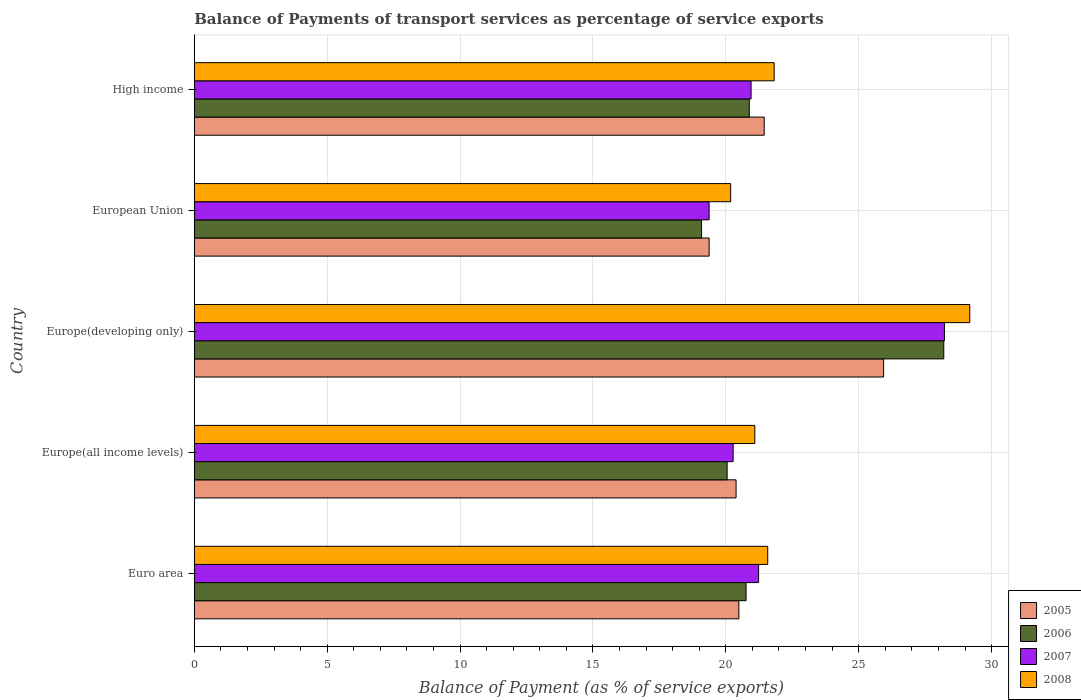Are the number of bars per tick equal to the number of legend labels?
Offer a very short reply. Yes. What is the label of the 5th group of bars from the top?
Keep it short and to the point. Euro area. What is the balance of payments of transport services in 2006 in High income?
Ensure brevity in your answer.  20.88. Across all countries, what is the maximum balance of payments of transport services in 2006?
Your answer should be compact. 28.2. Across all countries, what is the minimum balance of payments of transport services in 2008?
Offer a terse response. 20.18. In which country was the balance of payments of transport services in 2007 maximum?
Provide a succinct answer. Europe(developing only). In which country was the balance of payments of transport services in 2006 minimum?
Provide a succinct answer. European Union. What is the total balance of payments of transport services in 2007 in the graph?
Provide a short and direct response. 110.06. What is the difference between the balance of payments of transport services in 2007 in Euro area and that in European Union?
Make the answer very short. 1.86. What is the difference between the balance of payments of transport services in 2007 in Euro area and the balance of payments of transport services in 2006 in High income?
Your answer should be compact. 0.35. What is the average balance of payments of transport services in 2008 per country?
Give a very brief answer. 22.77. What is the difference between the balance of payments of transport services in 2007 and balance of payments of transport services in 2005 in European Union?
Make the answer very short. -0. In how many countries, is the balance of payments of transport services in 2006 greater than 6 %?
Your answer should be compact. 5. What is the ratio of the balance of payments of transport services in 2006 in Euro area to that in High income?
Provide a succinct answer. 0.99. Is the difference between the balance of payments of transport services in 2007 in European Union and High income greater than the difference between the balance of payments of transport services in 2005 in European Union and High income?
Your response must be concise. Yes. What is the difference between the highest and the second highest balance of payments of transport services in 2007?
Provide a short and direct response. 6.99. What is the difference between the highest and the lowest balance of payments of transport services in 2007?
Give a very brief answer. 8.85. Is the sum of the balance of payments of transport services in 2007 in Europe(all income levels) and European Union greater than the maximum balance of payments of transport services in 2005 across all countries?
Your answer should be compact. Yes. What does the 4th bar from the bottom in Europe(developing only) represents?
Offer a very short reply. 2008. How many bars are there?
Your response must be concise. 20. Are all the bars in the graph horizontal?
Offer a terse response. Yes. How many countries are there in the graph?
Give a very brief answer. 5. Are the values on the major ticks of X-axis written in scientific E-notation?
Your answer should be compact. No. Does the graph contain any zero values?
Keep it short and to the point. No. Does the graph contain grids?
Provide a succinct answer. Yes. How many legend labels are there?
Your answer should be compact. 4. What is the title of the graph?
Offer a terse response. Balance of Payments of transport services as percentage of service exports. What is the label or title of the X-axis?
Your answer should be compact. Balance of Payment (as % of service exports). What is the Balance of Payment (as % of service exports) of 2005 in Euro area?
Provide a short and direct response. 20.49. What is the Balance of Payment (as % of service exports) in 2006 in Euro area?
Your answer should be compact. 20.76. What is the Balance of Payment (as % of service exports) of 2007 in Euro area?
Your answer should be compact. 21.23. What is the Balance of Payment (as % of service exports) in 2008 in Euro area?
Keep it short and to the point. 21.58. What is the Balance of Payment (as % of service exports) of 2005 in Europe(all income levels)?
Offer a terse response. 20.39. What is the Balance of Payment (as % of service exports) of 2006 in Europe(all income levels)?
Provide a short and direct response. 20.05. What is the Balance of Payment (as % of service exports) in 2007 in Europe(all income levels)?
Provide a succinct answer. 20.28. What is the Balance of Payment (as % of service exports) of 2008 in Europe(all income levels)?
Keep it short and to the point. 21.09. What is the Balance of Payment (as % of service exports) of 2005 in Europe(developing only)?
Your response must be concise. 25.94. What is the Balance of Payment (as % of service exports) in 2006 in Europe(developing only)?
Provide a short and direct response. 28.2. What is the Balance of Payment (as % of service exports) in 2007 in Europe(developing only)?
Your response must be concise. 28.23. What is the Balance of Payment (as % of service exports) of 2008 in Europe(developing only)?
Make the answer very short. 29.18. What is the Balance of Payment (as % of service exports) in 2005 in European Union?
Give a very brief answer. 19.37. What is the Balance of Payment (as % of service exports) in 2006 in European Union?
Offer a terse response. 19.09. What is the Balance of Payment (as % of service exports) of 2007 in European Union?
Give a very brief answer. 19.37. What is the Balance of Payment (as % of service exports) of 2008 in European Union?
Offer a very short reply. 20.18. What is the Balance of Payment (as % of service exports) in 2005 in High income?
Your answer should be compact. 21.44. What is the Balance of Payment (as % of service exports) of 2006 in High income?
Ensure brevity in your answer.  20.88. What is the Balance of Payment (as % of service exports) of 2007 in High income?
Your response must be concise. 20.95. What is the Balance of Payment (as % of service exports) in 2008 in High income?
Give a very brief answer. 21.82. Across all countries, what is the maximum Balance of Payment (as % of service exports) of 2005?
Your answer should be compact. 25.94. Across all countries, what is the maximum Balance of Payment (as % of service exports) of 2006?
Provide a short and direct response. 28.2. Across all countries, what is the maximum Balance of Payment (as % of service exports) in 2007?
Offer a very short reply. 28.23. Across all countries, what is the maximum Balance of Payment (as % of service exports) of 2008?
Make the answer very short. 29.18. Across all countries, what is the minimum Balance of Payment (as % of service exports) in 2005?
Keep it short and to the point. 19.37. Across all countries, what is the minimum Balance of Payment (as % of service exports) of 2006?
Give a very brief answer. 19.09. Across all countries, what is the minimum Balance of Payment (as % of service exports) in 2007?
Offer a terse response. 19.37. Across all countries, what is the minimum Balance of Payment (as % of service exports) in 2008?
Offer a very short reply. 20.18. What is the total Balance of Payment (as % of service exports) of 2005 in the graph?
Provide a short and direct response. 107.63. What is the total Balance of Payment (as % of service exports) of 2006 in the graph?
Make the answer very short. 108.98. What is the total Balance of Payment (as % of service exports) of 2007 in the graph?
Offer a terse response. 110.06. What is the total Balance of Payment (as % of service exports) in 2008 in the graph?
Offer a very short reply. 113.85. What is the difference between the Balance of Payment (as % of service exports) in 2005 in Euro area and that in Europe(all income levels)?
Provide a succinct answer. 0.11. What is the difference between the Balance of Payment (as % of service exports) in 2006 in Euro area and that in Europe(all income levels)?
Your answer should be very brief. 0.71. What is the difference between the Balance of Payment (as % of service exports) in 2007 in Euro area and that in Europe(all income levels)?
Provide a short and direct response. 0.96. What is the difference between the Balance of Payment (as % of service exports) in 2008 in Euro area and that in Europe(all income levels)?
Provide a succinct answer. 0.49. What is the difference between the Balance of Payment (as % of service exports) of 2005 in Euro area and that in Europe(developing only)?
Keep it short and to the point. -5.45. What is the difference between the Balance of Payment (as % of service exports) in 2006 in Euro area and that in Europe(developing only)?
Make the answer very short. -7.44. What is the difference between the Balance of Payment (as % of service exports) of 2007 in Euro area and that in Europe(developing only)?
Your answer should be very brief. -6.99. What is the difference between the Balance of Payment (as % of service exports) in 2008 in Euro area and that in Europe(developing only)?
Give a very brief answer. -7.6. What is the difference between the Balance of Payment (as % of service exports) in 2005 in Euro area and that in European Union?
Offer a very short reply. 1.12. What is the difference between the Balance of Payment (as % of service exports) in 2006 in Euro area and that in European Union?
Your answer should be compact. 1.68. What is the difference between the Balance of Payment (as % of service exports) of 2007 in Euro area and that in European Union?
Your answer should be very brief. 1.86. What is the difference between the Balance of Payment (as % of service exports) in 2008 in Euro area and that in European Union?
Ensure brevity in your answer.  1.39. What is the difference between the Balance of Payment (as % of service exports) of 2005 in Euro area and that in High income?
Your answer should be very brief. -0.95. What is the difference between the Balance of Payment (as % of service exports) in 2006 in Euro area and that in High income?
Keep it short and to the point. -0.12. What is the difference between the Balance of Payment (as % of service exports) in 2007 in Euro area and that in High income?
Provide a succinct answer. 0.28. What is the difference between the Balance of Payment (as % of service exports) of 2008 in Euro area and that in High income?
Ensure brevity in your answer.  -0.24. What is the difference between the Balance of Payment (as % of service exports) of 2005 in Europe(all income levels) and that in Europe(developing only)?
Ensure brevity in your answer.  -5.55. What is the difference between the Balance of Payment (as % of service exports) of 2006 in Europe(all income levels) and that in Europe(developing only)?
Ensure brevity in your answer.  -8.15. What is the difference between the Balance of Payment (as % of service exports) of 2007 in Europe(all income levels) and that in Europe(developing only)?
Offer a terse response. -7.95. What is the difference between the Balance of Payment (as % of service exports) in 2008 in Europe(all income levels) and that in Europe(developing only)?
Offer a very short reply. -8.09. What is the difference between the Balance of Payment (as % of service exports) of 2005 in Europe(all income levels) and that in European Union?
Provide a short and direct response. 1.01. What is the difference between the Balance of Payment (as % of service exports) in 2006 in Europe(all income levels) and that in European Union?
Offer a terse response. 0.96. What is the difference between the Balance of Payment (as % of service exports) in 2007 in Europe(all income levels) and that in European Union?
Your answer should be very brief. 0.9. What is the difference between the Balance of Payment (as % of service exports) in 2008 in Europe(all income levels) and that in European Union?
Ensure brevity in your answer.  0.91. What is the difference between the Balance of Payment (as % of service exports) in 2005 in Europe(all income levels) and that in High income?
Keep it short and to the point. -1.06. What is the difference between the Balance of Payment (as % of service exports) in 2006 in Europe(all income levels) and that in High income?
Your answer should be compact. -0.83. What is the difference between the Balance of Payment (as % of service exports) in 2007 in Europe(all income levels) and that in High income?
Your response must be concise. -0.67. What is the difference between the Balance of Payment (as % of service exports) in 2008 in Europe(all income levels) and that in High income?
Make the answer very short. -0.73. What is the difference between the Balance of Payment (as % of service exports) in 2005 in Europe(developing only) and that in European Union?
Make the answer very short. 6.56. What is the difference between the Balance of Payment (as % of service exports) in 2006 in Europe(developing only) and that in European Union?
Keep it short and to the point. 9.11. What is the difference between the Balance of Payment (as % of service exports) of 2007 in Europe(developing only) and that in European Union?
Your response must be concise. 8.85. What is the difference between the Balance of Payment (as % of service exports) in 2008 in Europe(developing only) and that in European Union?
Make the answer very short. 9. What is the difference between the Balance of Payment (as % of service exports) of 2005 in Europe(developing only) and that in High income?
Your answer should be compact. 4.49. What is the difference between the Balance of Payment (as % of service exports) in 2006 in Europe(developing only) and that in High income?
Ensure brevity in your answer.  7.32. What is the difference between the Balance of Payment (as % of service exports) of 2007 in Europe(developing only) and that in High income?
Give a very brief answer. 7.28. What is the difference between the Balance of Payment (as % of service exports) of 2008 in Europe(developing only) and that in High income?
Your answer should be very brief. 7.36. What is the difference between the Balance of Payment (as % of service exports) in 2005 in European Union and that in High income?
Offer a terse response. -2.07. What is the difference between the Balance of Payment (as % of service exports) of 2006 in European Union and that in High income?
Provide a succinct answer. -1.8. What is the difference between the Balance of Payment (as % of service exports) of 2007 in European Union and that in High income?
Keep it short and to the point. -1.58. What is the difference between the Balance of Payment (as % of service exports) in 2008 in European Union and that in High income?
Ensure brevity in your answer.  -1.64. What is the difference between the Balance of Payment (as % of service exports) in 2005 in Euro area and the Balance of Payment (as % of service exports) in 2006 in Europe(all income levels)?
Provide a succinct answer. 0.44. What is the difference between the Balance of Payment (as % of service exports) in 2005 in Euro area and the Balance of Payment (as % of service exports) in 2007 in Europe(all income levels)?
Offer a terse response. 0.22. What is the difference between the Balance of Payment (as % of service exports) of 2005 in Euro area and the Balance of Payment (as % of service exports) of 2008 in Europe(all income levels)?
Provide a short and direct response. -0.6. What is the difference between the Balance of Payment (as % of service exports) of 2006 in Euro area and the Balance of Payment (as % of service exports) of 2007 in Europe(all income levels)?
Ensure brevity in your answer.  0.49. What is the difference between the Balance of Payment (as % of service exports) in 2006 in Euro area and the Balance of Payment (as % of service exports) in 2008 in Europe(all income levels)?
Offer a terse response. -0.33. What is the difference between the Balance of Payment (as % of service exports) in 2007 in Euro area and the Balance of Payment (as % of service exports) in 2008 in Europe(all income levels)?
Provide a succinct answer. 0.14. What is the difference between the Balance of Payment (as % of service exports) in 2005 in Euro area and the Balance of Payment (as % of service exports) in 2006 in Europe(developing only)?
Keep it short and to the point. -7.71. What is the difference between the Balance of Payment (as % of service exports) in 2005 in Euro area and the Balance of Payment (as % of service exports) in 2007 in Europe(developing only)?
Your answer should be very brief. -7.73. What is the difference between the Balance of Payment (as % of service exports) in 2005 in Euro area and the Balance of Payment (as % of service exports) in 2008 in Europe(developing only)?
Give a very brief answer. -8.69. What is the difference between the Balance of Payment (as % of service exports) in 2006 in Euro area and the Balance of Payment (as % of service exports) in 2007 in Europe(developing only)?
Make the answer very short. -7.46. What is the difference between the Balance of Payment (as % of service exports) of 2006 in Euro area and the Balance of Payment (as % of service exports) of 2008 in Europe(developing only)?
Make the answer very short. -8.42. What is the difference between the Balance of Payment (as % of service exports) of 2007 in Euro area and the Balance of Payment (as % of service exports) of 2008 in Europe(developing only)?
Provide a short and direct response. -7.95. What is the difference between the Balance of Payment (as % of service exports) of 2005 in Euro area and the Balance of Payment (as % of service exports) of 2006 in European Union?
Ensure brevity in your answer.  1.4. What is the difference between the Balance of Payment (as % of service exports) in 2005 in Euro area and the Balance of Payment (as % of service exports) in 2007 in European Union?
Offer a terse response. 1.12. What is the difference between the Balance of Payment (as % of service exports) of 2005 in Euro area and the Balance of Payment (as % of service exports) of 2008 in European Union?
Offer a very short reply. 0.31. What is the difference between the Balance of Payment (as % of service exports) of 2006 in Euro area and the Balance of Payment (as % of service exports) of 2007 in European Union?
Your response must be concise. 1.39. What is the difference between the Balance of Payment (as % of service exports) in 2006 in Euro area and the Balance of Payment (as % of service exports) in 2008 in European Union?
Keep it short and to the point. 0.58. What is the difference between the Balance of Payment (as % of service exports) of 2007 in Euro area and the Balance of Payment (as % of service exports) of 2008 in European Union?
Your answer should be compact. 1.05. What is the difference between the Balance of Payment (as % of service exports) of 2005 in Euro area and the Balance of Payment (as % of service exports) of 2006 in High income?
Ensure brevity in your answer.  -0.39. What is the difference between the Balance of Payment (as % of service exports) of 2005 in Euro area and the Balance of Payment (as % of service exports) of 2007 in High income?
Keep it short and to the point. -0.46. What is the difference between the Balance of Payment (as % of service exports) of 2005 in Euro area and the Balance of Payment (as % of service exports) of 2008 in High income?
Offer a very short reply. -1.33. What is the difference between the Balance of Payment (as % of service exports) of 2006 in Euro area and the Balance of Payment (as % of service exports) of 2007 in High income?
Provide a short and direct response. -0.19. What is the difference between the Balance of Payment (as % of service exports) of 2006 in Euro area and the Balance of Payment (as % of service exports) of 2008 in High income?
Keep it short and to the point. -1.06. What is the difference between the Balance of Payment (as % of service exports) of 2007 in Euro area and the Balance of Payment (as % of service exports) of 2008 in High income?
Your answer should be very brief. -0.59. What is the difference between the Balance of Payment (as % of service exports) in 2005 in Europe(all income levels) and the Balance of Payment (as % of service exports) in 2006 in Europe(developing only)?
Offer a terse response. -7.82. What is the difference between the Balance of Payment (as % of service exports) of 2005 in Europe(all income levels) and the Balance of Payment (as % of service exports) of 2007 in Europe(developing only)?
Offer a terse response. -7.84. What is the difference between the Balance of Payment (as % of service exports) in 2005 in Europe(all income levels) and the Balance of Payment (as % of service exports) in 2008 in Europe(developing only)?
Provide a succinct answer. -8.79. What is the difference between the Balance of Payment (as % of service exports) of 2006 in Europe(all income levels) and the Balance of Payment (as % of service exports) of 2007 in Europe(developing only)?
Your answer should be compact. -8.18. What is the difference between the Balance of Payment (as % of service exports) in 2006 in Europe(all income levels) and the Balance of Payment (as % of service exports) in 2008 in Europe(developing only)?
Give a very brief answer. -9.13. What is the difference between the Balance of Payment (as % of service exports) of 2007 in Europe(all income levels) and the Balance of Payment (as % of service exports) of 2008 in Europe(developing only)?
Make the answer very short. -8.9. What is the difference between the Balance of Payment (as % of service exports) in 2005 in Europe(all income levels) and the Balance of Payment (as % of service exports) in 2006 in European Union?
Your answer should be compact. 1.3. What is the difference between the Balance of Payment (as % of service exports) in 2005 in Europe(all income levels) and the Balance of Payment (as % of service exports) in 2007 in European Union?
Offer a terse response. 1.01. What is the difference between the Balance of Payment (as % of service exports) in 2005 in Europe(all income levels) and the Balance of Payment (as % of service exports) in 2008 in European Union?
Keep it short and to the point. 0.2. What is the difference between the Balance of Payment (as % of service exports) in 2006 in Europe(all income levels) and the Balance of Payment (as % of service exports) in 2007 in European Union?
Provide a succinct answer. 0.68. What is the difference between the Balance of Payment (as % of service exports) of 2006 in Europe(all income levels) and the Balance of Payment (as % of service exports) of 2008 in European Union?
Make the answer very short. -0.13. What is the difference between the Balance of Payment (as % of service exports) in 2007 in Europe(all income levels) and the Balance of Payment (as % of service exports) in 2008 in European Union?
Your answer should be compact. 0.09. What is the difference between the Balance of Payment (as % of service exports) of 2005 in Europe(all income levels) and the Balance of Payment (as % of service exports) of 2006 in High income?
Give a very brief answer. -0.5. What is the difference between the Balance of Payment (as % of service exports) in 2005 in Europe(all income levels) and the Balance of Payment (as % of service exports) in 2007 in High income?
Your response must be concise. -0.56. What is the difference between the Balance of Payment (as % of service exports) of 2005 in Europe(all income levels) and the Balance of Payment (as % of service exports) of 2008 in High income?
Ensure brevity in your answer.  -1.43. What is the difference between the Balance of Payment (as % of service exports) in 2006 in Europe(all income levels) and the Balance of Payment (as % of service exports) in 2007 in High income?
Provide a short and direct response. -0.9. What is the difference between the Balance of Payment (as % of service exports) of 2006 in Europe(all income levels) and the Balance of Payment (as % of service exports) of 2008 in High income?
Keep it short and to the point. -1.77. What is the difference between the Balance of Payment (as % of service exports) of 2007 in Europe(all income levels) and the Balance of Payment (as % of service exports) of 2008 in High income?
Keep it short and to the point. -1.54. What is the difference between the Balance of Payment (as % of service exports) of 2005 in Europe(developing only) and the Balance of Payment (as % of service exports) of 2006 in European Union?
Your answer should be very brief. 6.85. What is the difference between the Balance of Payment (as % of service exports) of 2005 in Europe(developing only) and the Balance of Payment (as % of service exports) of 2007 in European Union?
Ensure brevity in your answer.  6.57. What is the difference between the Balance of Payment (as % of service exports) in 2005 in Europe(developing only) and the Balance of Payment (as % of service exports) in 2008 in European Union?
Offer a very short reply. 5.75. What is the difference between the Balance of Payment (as % of service exports) of 2006 in Europe(developing only) and the Balance of Payment (as % of service exports) of 2007 in European Union?
Your response must be concise. 8.83. What is the difference between the Balance of Payment (as % of service exports) of 2006 in Europe(developing only) and the Balance of Payment (as % of service exports) of 2008 in European Union?
Your response must be concise. 8.02. What is the difference between the Balance of Payment (as % of service exports) of 2007 in Europe(developing only) and the Balance of Payment (as % of service exports) of 2008 in European Union?
Provide a succinct answer. 8.04. What is the difference between the Balance of Payment (as % of service exports) of 2005 in Europe(developing only) and the Balance of Payment (as % of service exports) of 2006 in High income?
Your answer should be compact. 5.05. What is the difference between the Balance of Payment (as % of service exports) in 2005 in Europe(developing only) and the Balance of Payment (as % of service exports) in 2007 in High income?
Offer a terse response. 4.99. What is the difference between the Balance of Payment (as % of service exports) in 2005 in Europe(developing only) and the Balance of Payment (as % of service exports) in 2008 in High income?
Ensure brevity in your answer.  4.12. What is the difference between the Balance of Payment (as % of service exports) of 2006 in Europe(developing only) and the Balance of Payment (as % of service exports) of 2007 in High income?
Ensure brevity in your answer.  7.25. What is the difference between the Balance of Payment (as % of service exports) in 2006 in Europe(developing only) and the Balance of Payment (as % of service exports) in 2008 in High income?
Provide a short and direct response. 6.38. What is the difference between the Balance of Payment (as % of service exports) of 2007 in Europe(developing only) and the Balance of Payment (as % of service exports) of 2008 in High income?
Your answer should be very brief. 6.41. What is the difference between the Balance of Payment (as % of service exports) of 2005 in European Union and the Balance of Payment (as % of service exports) of 2006 in High income?
Offer a very short reply. -1.51. What is the difference between the Balance of Payment (as % of service exports) of 2005 in European Union and the Balance of Payment (as % of service exports) of 2007 in High income?
Give a very brief answer. -1.58. What is the difference between the Balance of Payment (as % of service exports) of 2005 in European Union and the Balance of Payment (as % of service exports) of 2008 in High income?
Provide a succinct answer. -2.45. What is the difference between the Balance of Payment (as % of service exports) of 2006 in European Union and the Balance of Payment (as % of service exports) of 2007 in High income?
Give a very brief answer. -1.86. What is the difference between the Balance of Payment (as % of service exports) of 2006 in European Union and the Balance of Payment (as % of service exports) of 2008 in High income?
Offer a very short reply. -2.73. What is the difference between the Balance of Payment (as % of service exports) in 2007 in European Union and the Balance of Payment (as % of service exports) in 2008 in High income?
Your response must be concise. -2.45. What is the average Balance of Payment (as % of service exports) in 2005 per country?
Offer a terse response. 21.53. What is the average Balance of Payment (as % of service exports) of 2006 per country?
Your response must be concise. 21.8. What is the average Balance of Payment (as % of service exports) of 2007 per country?
Give a very brief answer. 22.01. What is the average Balance of Payment (as % of service exports) of 2008 per country?
Your answer should be compact. 22.77. What is the difference between the Balance of Payment (as % of service exports) in 2005 and Balance of Payment (as % of service exports) in 2006 in Euro area?
Your answer should be compact. -0.27. What is the difference between the Balance of Payment (as % of service exports) in 2005 and Balance of Payment (as % of service exports) in 2007 in Euro area?
Your response must be concise. -0.74. What is the difference between the Balance of Payment (as % of service exports) in 2005 and Balance of Payment (as % of service exports) in 2008 in Euro area?
Your answer should be very brief. -1.09. What is the difference between the Balance of Payment (as % of service exports) in 2006 and Balance of Payment (as % of service exports) in 2007 in Euro area?
Offer a very short reply. -0.47. What is the difference between the Balance of Payment (as % of service exports) of 2006 and Balance of Payment (as % of service exports) of 2008 in Euro area?
Keep it short and to the point. -0.81. What is the difference between the Balance of Payment (as % of service exports) in 2007 and Balance of Payment (as % of service exports) in 2008 in Euro area?
Your response must be concise. -0.34. What is the difference between the Balance of Payment (as % of service exports) in 2005 and Balance of Payment (as % of service exports) in 2006 in Europe(all income levels)?
Ensure brevity in your answer.  0.34. What is the difference between the Balance of Payment (as % of service exports) in 2005 and Balance of Payment (as % of service exports) in 2007 in Europe(all income levels)?
Offer a very short reply. 0.11. What is the difference between the Balance of Payment (as % of service exports) in 2005 and Balance of Payment (as % of service exports) in 2008 in Europe(all income levels)?
Your response must be concise. -0.71. What is the difference between the Balance of Payment (as % of service exports) in 2006 and Balance of Payment (as % of service exports) in 2007 in Europe(all income levels)?
Your answer should be very brief. -0.23. What is the difference between the Balance of Payment (as % of service exports) in 2006 and Balance of Payment (as % of service exports) in 2008 in Europe(all income levels)?
Make the answer very short. -1.04. What is the difference between the Balance of Payment (as % of service exports) in 2007 and Balance of Payment (as % of service exports) in 2008 in Europe(all income levels)?
Keep it short and to the point. -0.82. What is the difference between the Balance of Payment (as % of service exports) in 2005 and Balance of Payment (as % of service exports) in 2006 in Europe(developing only)?
Provide a short and direct response. -2.26. What is the difference between the Balance of Payment (as % of service exports) in 2005 and Balance of Payment (as % of service exports) in 2007 in Europe(developing only)?
Provide a succinct answer. -2.29. What is the difference between the Balance of Payment (as % of service exports) in 2005 and Balance of Payment (as % of service exports) in 2008 in Europe(developing only)?
Your response must be concise. -3.24. What is the difference between the Balance of Payment (as % of service exports) in 2006 and Balance of Payment (as % of service exports) in 2007 in Europe(developing only)?
Your response must be concise. -0.02. What is the difference between the Balance of Payment (as % of service exports) in 2006 and Balance of Payment (as % of service exports) in 2008 in Europe(developing only)?
Give a very brief answer. -0.98. What is the difference between the Balance of Payment (as % of service exports) of 2007 and Balance of Payment (as % of service exports) of 2008 in Europe(developing only)?
Make the answer very short. -0.95. What is the difference between the Balance of Payment (as % of service exports) in 2005 and Balance of Payment (as % of service exports) in 2006 in European Union?
Provide a short and direct response. 0.28. What is the difference between the Balance of Payment (as % of service exports) of 2005 and Balance of Payment (as % of service exports) of 2007 in European Union?
Offer a terse response. 0. What is the difference between the Balance of Payment (as % of service exports) in 2005 and Balance of Payment (as % of service exports) in 2008 in European Union?
Keep it short and to the point. -0.81. What is the difference between the Balance of Payment (as % of service exports) of 2006 and Balance of Payment (as % of service exports) of 2007 in European Union?
Give a very brief answer. -0.28. What is the difference between the Balance of Payment (as % of service exports) in 2006 and Balance of Payment (as % of service exports) in 2008 in European Union?
Your answer should be very brief. -1.1. What is the difference between the Balance of Payment (as % of service exports) in 2007 and Balance of Payment (as % of service exports) in 2008 in European Union?
Give a very brief answer. -0.81. What is the difference between the Balance of Payment (as % of service exports) in 2005 and Balance of Payment (as % of service exports) in 2006 in High income?
Provide a succinct answer. 0.56. What is the difference between the Balance of Payment (as % of service exports) in 2005 and Balance of Payment (as % of service exports) in 2007 in High income?
Offer a very short reply. 0.49. What is the difference between the Balance of Payment (as % of service exports) in 2005 and Balance of Payment (as % of service exports) in 2008 in High income?
Your response must be concise. -0.37. What is the difference between the Balance of Payment (as % of service exports) of 2006 and Balance of Payment (as % of service exports) of 2007 in High income?
Offer a very short reply. -0.07. What is the difference between the Balance of Payment (as % of service exports) of 2006 and Balance of Payment (as % of service exports) of 2008 in High income?
Give a very brief answer. -0.94. What is the difference between the Balance of Payment (as % of service exports) of 2007 and Balance of Payment (as % of service exports) of 2008 in High income?
Your response must be concise. -0.87. What is the ratio of the Balance of Payment (as % of service exports) of 2005 in Euro area to that in Europe(all income levels)?
Your answer should be compact. 1.01. What is the ratio of the Balance of Payment (as % of service exports) in 2006 in Euro area to that in Europe(all income levels)?
Give a very brief answer. 1.04. What is the ratio of the Balance of Payment (as % of service exports) of 2007 in Euro area to that in Europe(all income levels)?
Your response must be concise. 1.05. What is the ratio of the Balance of Payment (as % of service exports) of 2005 in Euro area to that in Europe(developing only)?
Provide a succinct answer. 0.79. What is the ratio of the Balance of Payment (as % of service exports) in 2006 in Euro area to that in Europe(developing only)?
Offer a very short reply. 0.74. What is the ratio of the Balance of Payment (as % of service exports) in 2007 in Euro area to that in Europe(developing only)?
Make the answer very short. 0.75. What is the ratio of the Balance of Payment (as % of service exports) of 2008 in Euro area to that in Europe(developing only)?
Offer a very short reply. 0.74. What is the ratio of the Balance of Payment (as % of service exports) of 2005 in Euro area to that in European Union?
Give a very brief answer. 1.06. What is the ratio of the Balance of Payment (as % of service exports) in 2006 in Euro area to that in European Union?
Offer a terse response. 1.09. What is the ratio of the Balance of Payment (as % of service exports) of 2007 in Euro area to that in European Union?
Offer a very short reply. 1.1. What is the ratio of the Balance of Payment (as % of service exports) in 2008 in Euro area to that in European Union?
Keep it short and to the point. 1.07. What is the ratio of the Balance of Payment (as % of service exports) in 2005 in Euro area to that in High income?
Make the answer very short. 0.96. What is the ratio of the Balance of Payment (as % of service exports) in 2007 in Euro area to that in High income?
Offer a terse response. 1.01. What is the ratio of the Balance of Payment (as % of service exports) of 2008 in Euro area to that in High income?
Offer a very short reply. 0.99. What is the ratio of the Balance of Payment (as % of service exports) in 2005 in Europe(all income levels) to that in Europe(developing only)?
Ensure brevity in your answer.  0.79. What is the ratio of the Balance of Payment (as % of service exports) of 2006 in Europe(all income levels) to that in Europe(developing only)?
Make the answer very short. 0.71. What is the ratio of the Balance of Payment (as % of service exports) of 2007 in Europe(all income levels) to that in Europe(developing only)?
Offer a very short reply. 0.72. What is the ratio of the Balance of Payment (as % of service exports) of 2008 in Europe(all income levels) to that in Europe(developing only)?
Provide a short and direct response. 0.72. What is the ratio of the Balance of Payment (as % of service exports) in 2005 in Europe(all income levels) to that in European Union?
Ensure brevity in your answer.  1.05. What is the ratio of the Balance of Payment (as % of service exports) of 2006 in Europe(all income levels) to that in European Union?
Your response must be concise. 1.05. What is the ratio of the Balance of Payment (as % of service exports) of 2007 in Europe(all income levels) to that in European Union?
Ensure brevity in your answer.  1.05. What is the ratio of the Balance of Payment (as % of service exports) of 2008 in Europe(all income levels) to that in European Union?
Provide a succinct answer. 1.04. What is the ratio of the Balance of Payment (as % of service exports) in 2005 in Europe(all income levels) to that in High income?
Your answer should be very brief. 0.95. What is the ratio of the Balance of Payment (as % of service exports) of 2006 in Europe(all income levels) to that in High income?
Your answer should be very brief. 0.96. What is the ratio of the Balance of Payment (as % of service exports) of 2007 in Europe(all income levels) to that in High income?
Your answer should be very brief. 0.97. What is the ratio of the Balance of Payment (as % of service exports) in 2008 in Europe(all income levels) to that in High income?
Your answer should be very brief. 0.97. What is the ratio of the Balance of Payment (as % of service exports) of 2005 in Europe(developing only) to that in European Union?
Provide a succinct answer. 1.34. What is the ratio of the Balance of Payment (as % of service exports) of 2006 in Europe(developing only) to that in European Union?
Your answer should be very brief. 1.48. What is the ratio of the Balance of Payment (as % of service exports) in 2007 in Europe(developing only) to that in European Union?
Provide a short and direct response. 1.46. What is the ratio of the Balance of Payment (as % of service exports) of 2008 in Europe(developing only) to that in European Union?
Make the answer very short. 1.45. What is the ratio of the Balance of Payment (as % of service exports) of 2005 in Europe(developing only) to that in High income?
Offer a terse response. 1.21. What is the ratio of the Balance of Payment (as % of service exports) of 2006 in Europe(developing only) to that in High income?
Make the answer very short. 1.35. What is the ratio of the Balance of Payment (as % of service exports) in 2007 in Europe(developing only) to that in High income?
Provide a short and direct response. 1.35. What is the ratio of the Balance of Payment (as % of service exports) in 2008 in Europe(developing only) to that in High income?
Your answer should be very brief. 1.34. What is the ratio of the Balance of Payment (as % of service exports) in 2005 in European Union to that in High income?
Ensure brevity in your answer.  0.9. What is the ratio of the Balance of Payment (as % of service exports) in 2006 in European Union to that in High income?
Your answer should be very brief. 0.91. What is the ratio of the Balance of Payment (as % of service exports) of 2007 in European Union to that in High income?
Make the answer very short. 0.92. What is the ratio of the Balance of Payment (as % of service exports) of 2008 in European Union to that in High income?
Give a very brief answer. 0.93. What is the difference between the highest and the second highest Balance of Payment (as % of service exports) of 2005?
Provide a succinct answer. 4.49. What is the difference between the highest and the second highest Balance of Payment (as % of service exports) in 2006?
Keep it short and to the point. 7.32. What is the difference between the highest and the second highest Balance of Payment (as % of service exports) in 2007?
Give a very brief answer. 6.99. What is the difference between the highest and the second highest Balance of Payment (as % of service exports) in 2008?
Give a very brief answer. 7.36. What is the difference between the highest and the lowest Balance of Payment (as % of service exports) of 2005?
Ensure brevity in your answer.  6.56. What is the difference between the highest and the lowest Balance of Payment (as % of service exports) in 2006?
Your answer should be very brief. 9.11. What is the difference between the highest and the lowest Balance of Payment (as % of service exports) in 2007?
Ensure brevity in your answer.  8.85. What is the difference between the highest and the lowest Balance of Payment (as % of service exports) in 2008?
Your answer should be very brief. 9. 